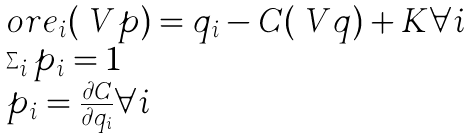<formula> <loc_0><loc_0><loc_500><loc_500>\begin{array} { l } o r e _ { i } ( \ V { p } ) = q _ { i } - C ( \ V { q } ) + K \forall i \\ \sum _ { i } p _ { i } = 1 \\ p _ { i } = \frac { \partial C } { \partial q _ { i } } \forall i \\ \end{array}</formula> 